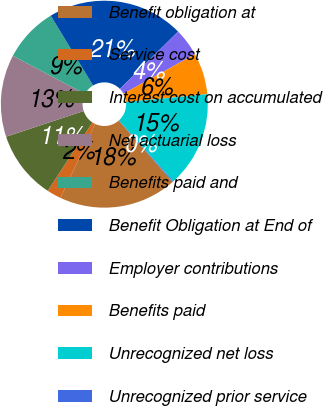Convert chart. <chart><loc_0><loc_0><loc_500><loc_500><pie_chart><fcel>Benefit obligation at<fcel>Service cost<fcel>Interest cost on accumulated<fcel>Net actuarial loss<fcel>Benefits paid and<fcel>Benefit Obligation at End of<fcel>Employer contributions<fcel>Benefits paid<fcel>Unrecognized net loss<fcel>Unrecognized prior service<nl><fcel>18.44%<fcel>2.24%<fcel>10.71%<fcel>12.83%<fcel>8.59%<fcel>21.29%<fcel>4.36%<fcel>6.48%<fcel>14.94%<fcel>0.13%<nl></chart> 